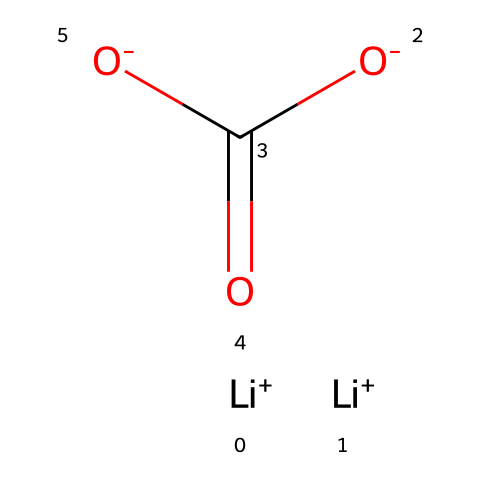What is the chemical formula for lithium carbonate? The SMILES representation shows two lithium ions (Li) and one carbonate ion (C(=O)[O-]), which corresponds to the formula Li2CO3.
Answer: Li2CO3 How many lithium atoms are present in this structure? The SMILES notation [Li+] indicates two lithium cations (Li), as there are two occurrences of [Li+] in the representation.
Answer: 2 How many oxygen atoms are in the carbonate ion of lithium carbonate? The carbonate ion is represented as C(=O)[O-], showing that there are three oxygen atoms: one in a double bond to carbon and two as single-bonded to the carbon.
Answer: 3 What type of chemical compound is lithium carbonate? Lithium carbonate contains an alkali metal (lithium) and a carbonate group, classifying it as an inorganic salt.
Answer: inorganic salt What charge does each lithium ion carry? Each lithium ion is represented with the notation [Li+], indicating that they each carry a single positive charge.
Answer: +1 What role does lithium carbonate play in mental health treatment? Lithium carbonate is primarily used as a mood stabilizer in the treatment of bipolar disorder, helping to balance mood swings.
Answer: mood stabilizer How does the structure of lithium carbonate facilitate its function as an electrolyte? The presence of lithium cations contributes to its ability to dissociate in solution, carrying electric charge, which is essential for its function as an electrolyte.
Answer: dissociation 